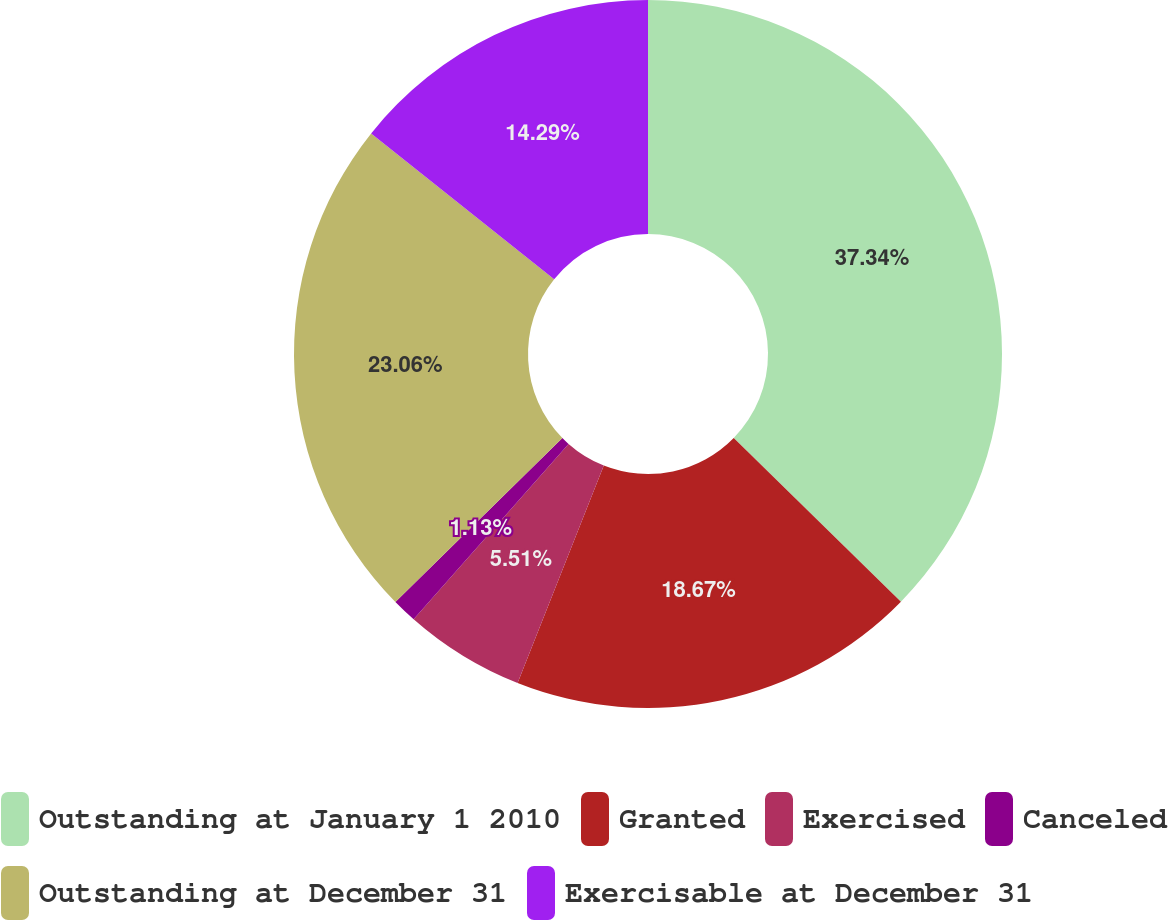Convert chart. <chart><loc_0><loc_0><loc_500><loc_500><pie_chart><fcel>Outstanding at January 1 2010<fcel>Granted<fcel>Exercised<fcel>Canceled<fcel>Outstanding at December 31<fcel>Exercisable at December 31<nl><fcel>37.33%<fcel>18.67%<fcel>5.51%<fcel>1.13%<fcel>23.06%<fcel>14.29%<nl></chart> 